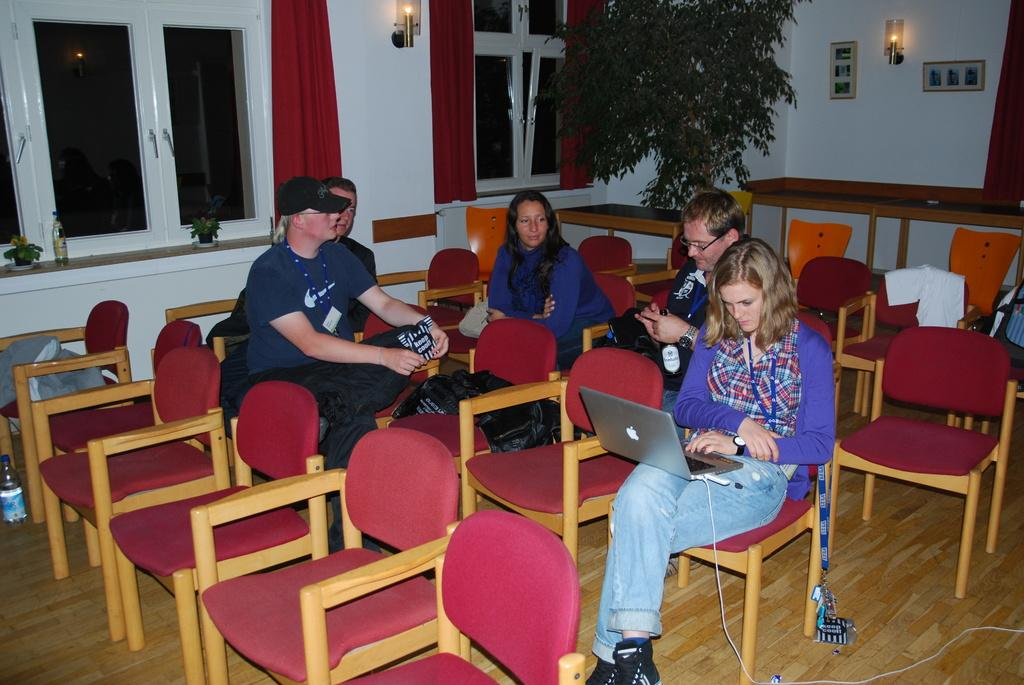What type of furniture is present in the room? There are chairs in the room. What are the people in the room doing? People are sitting on the chairs. Can you describe the woman in the room? The woman in the room is working on a laptop. What can be seen in the background of the room? There are windows, curtains, light, and a plant visible in the background. Can you tell me how many holes are present in the plant in the image? There is no mention of holes in the plant in the image; it is not possible to determine the number of holes from the provided facts. 